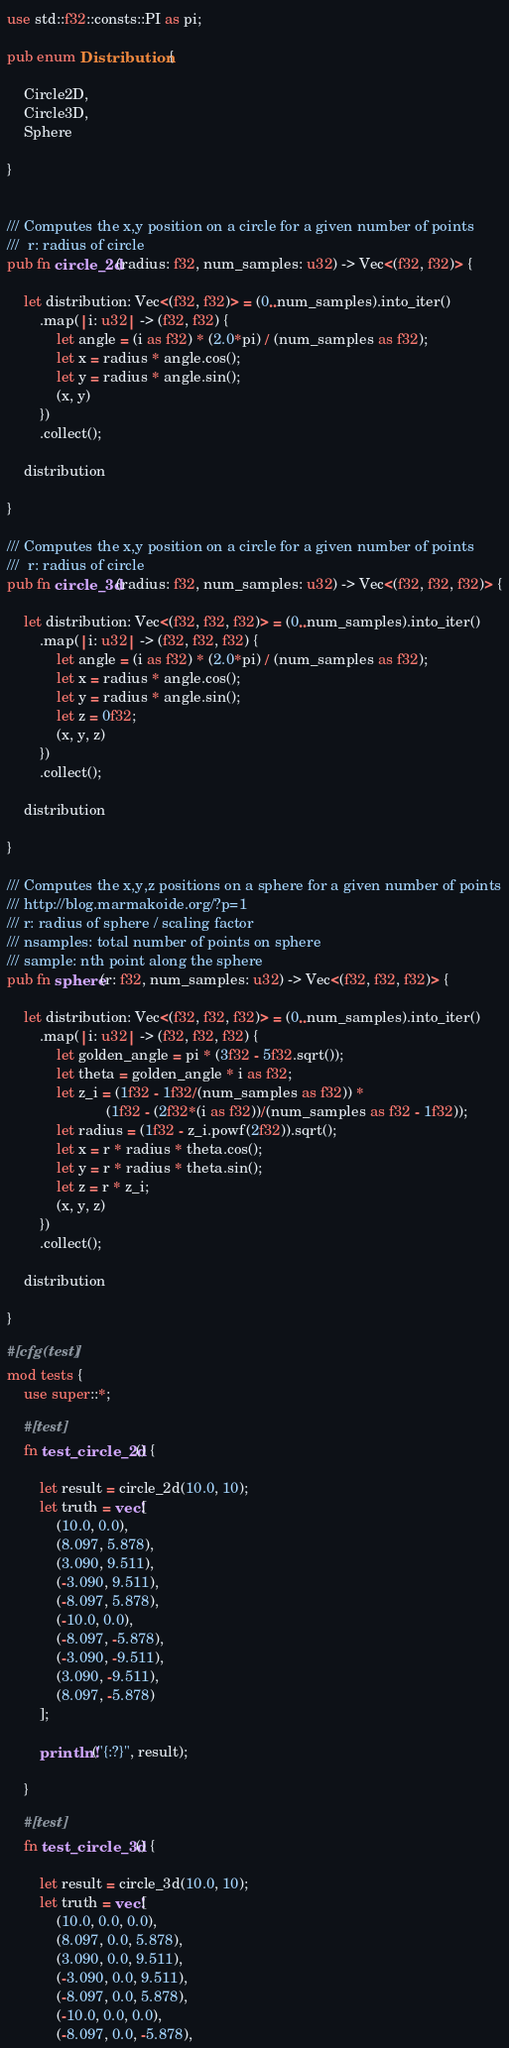<code> <loc_0><loc_0><loc_500><loc_500><_Rust_>
use std::f32::consts::PI as pi;

pub enum Distribution {

    Circle2D,
    Circle3D,
    Sphere

}


/// Computes the x,y position on a circle for a given number of points
///  r: radius of circle
pub fn circle_2d(radius: f32, num_samples: u32) -> Vec<(f32, f32)> {

    let distribution: Vec<(f32, f32)> = (0..num_samples).into_iter()
        .map(|i: u32| -> (f32, f32) {
            let angle = (i as f32) * (2.0*pi) / (num_samples as f32);
            let x = radius * angle.cos();
            let y = radius * angle.sin();
            (x, y)
        })
        .collect();

    distribution

}

/// Computes the x,y position on a circle for a given number of points
///  r: radius of circle
pub fn circle_3d(radius: f32, num_samples: u32) -> Vec<(f32, f32, f32)> {

    let distribution: Vec<(f32, f32, f32)> = (0..num_samples).into_iter()
        .map(|i: u32| -> (f32, f32, f32) {
            let angle = (i as f32) * (2.0*pi) / (num_samples as f32);
            let x = radius * angle.cos();
            let y = radius * angle.sin();
            let z = 0f32;
            (x, y, z)
        })
        .collect();

    distribution

}

/// Computes the x,y,z positions on a sphere for a given number of points
/// http://blog.marmakoide.org/?p=1
/// r: radius of sphere / scaling factor
/// nsamples: total number of points on sphere
/// sample: nth point along the sphere
pub fn sphere(r: f32, num_samples: u32) -> Vec<(f32, f32, f32)> {

    let distribution: Vec<(f32, f32, f32)> = (0..num_samples).into_iter()
        .map(|i: u32| -> (f32, f32, f32) {
            let golden_angle = pi * (3f32 - 5f32.sqrt());
            let theta = golden_angle * i as f32;
            let z_i = (1f32 - 1f32/(num_samples as f32)) * 
                        (1f32 - (2f32*(i as f32))/(num_samples as f32 - 1f32));
            let radius = (1f32 - z_i.powf(2f32)).sqrt();
            let x = r * radius * theta.cos();
            let y = r * radius * theta.sin();
            let z = r * z_i;
            (x, y, z)
        })
        .collect();

    distribution

}

#[cfg(test)]
mod tests {
    use super::*;

    #[test]
    fn test_circle_2d() {

        let result = circle_2d(10.0, 10);
        let truth = vec![
            (10.0, 0.0),
            (8.097, 5.878),
            (3.090, 9.511),
            (-3.090, 9.511),
            (-8.097, 5.878),
            (-10.0, 0.0),
            (-8.097, -5.878),
            (-3.090, -9.511),
            (3.090, -9.511),
            (8.097, -5.878)
        ];

        println!("{:?}", result);

    }

    #[test]
    fn test_circle_3d() {

        let result = circle_3d(10.0, 10);
        let truth = vec![
            (10.0, 0.0, 0.0),
            (8.097, 0.0, 5.878),
            (3.090, 0.0, 9.511),
            (-3.090, 0.0, 9.511),
            (-8.097, 0.0, 5.878),
            (-10.0, 0.0, 0.0),
            (-8.097, 0.0, -5.878),</code> 